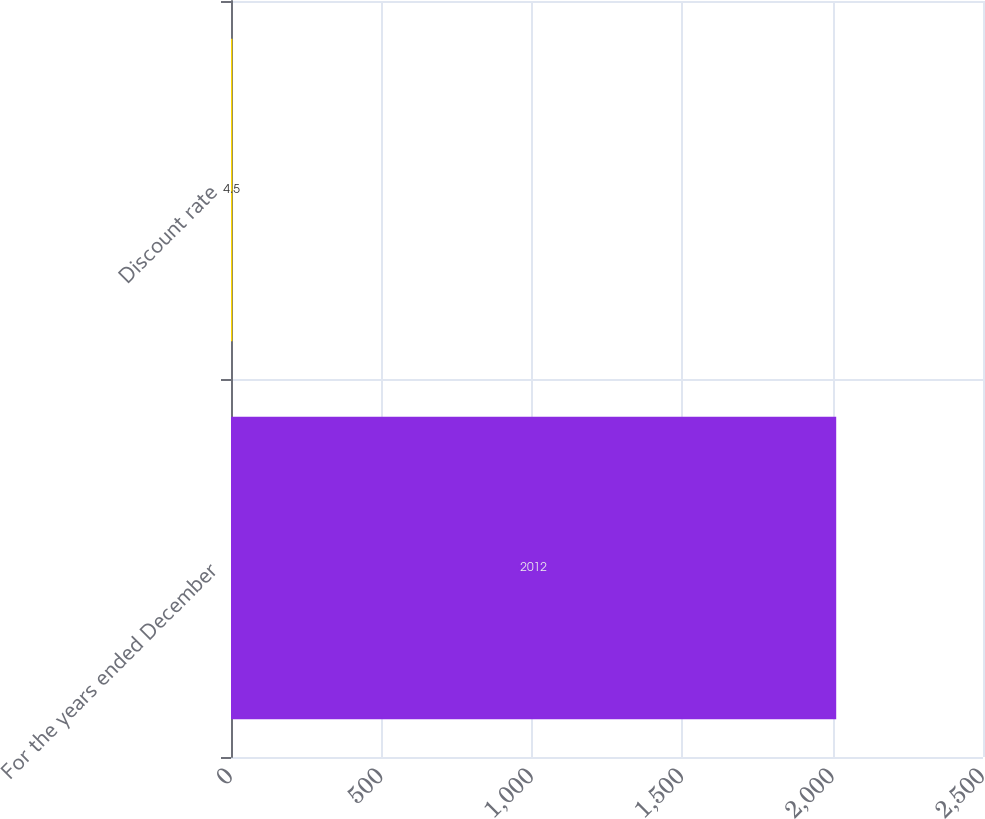Convert chart. <chart><loc_0><loc_0><loc_500><loc_500><bar_chart><fcel>For the years ended December<fcel>Discount rate<nl><fcel>2012<fcel>4.5<nl></chart> 